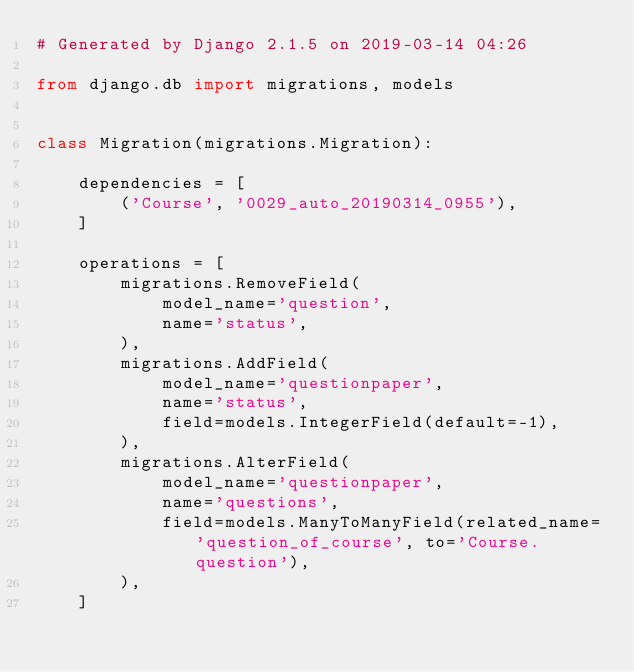Convert code to text. <code><loc_0><loc_0><loc_500><loc_500><_Python_># Generated by Django 2.1.5 on 2019-03-14 04:26

from django.db import migrations, models


class Migration(migrations.Migration):

    dependencies = [
        ('Course', '0029_auto_20190314_0955'),
    ]

    operations = [
        migrations.RemoveField(
            model_name='question',
            name='status',
        ),
        migrations.AddField(
            model_name='questionpaper',
            name='status',
            field=models.IntegerField(default=-1),
        ),
        migrations.AlterField(
            model_name='questionpaper',
            name='questions',
            field=models.ManyToManyField(related_name='question_of_course', to='Course.question'),
        ),
    ]
</code> 